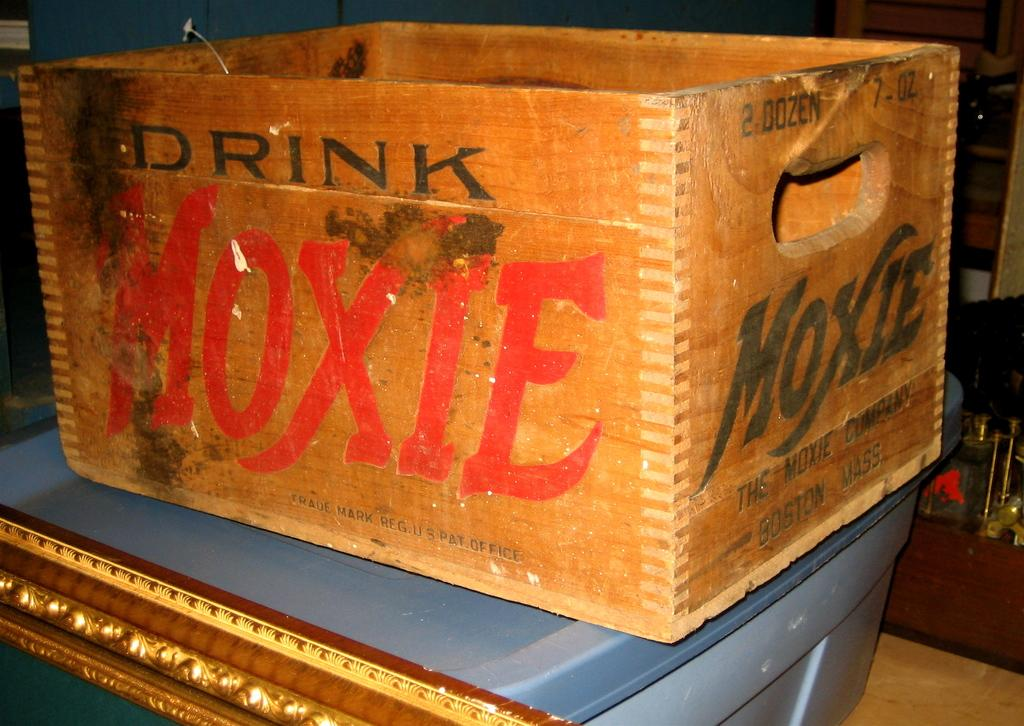<image>
Provide a brief description of the given image. Brown wooden box that says Drink Moxie on it. 